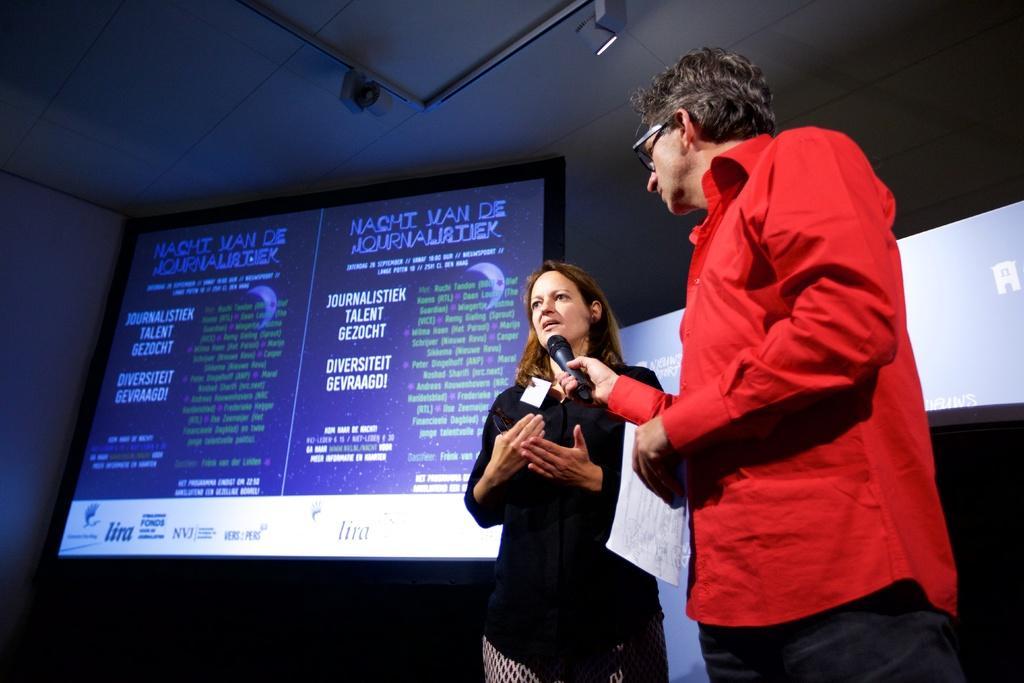Could you give a brief overview of what you see in this image? In this picture we can see a man, woman and man is holding a mic and in the background we can see screens, wall, roof and some objects. 